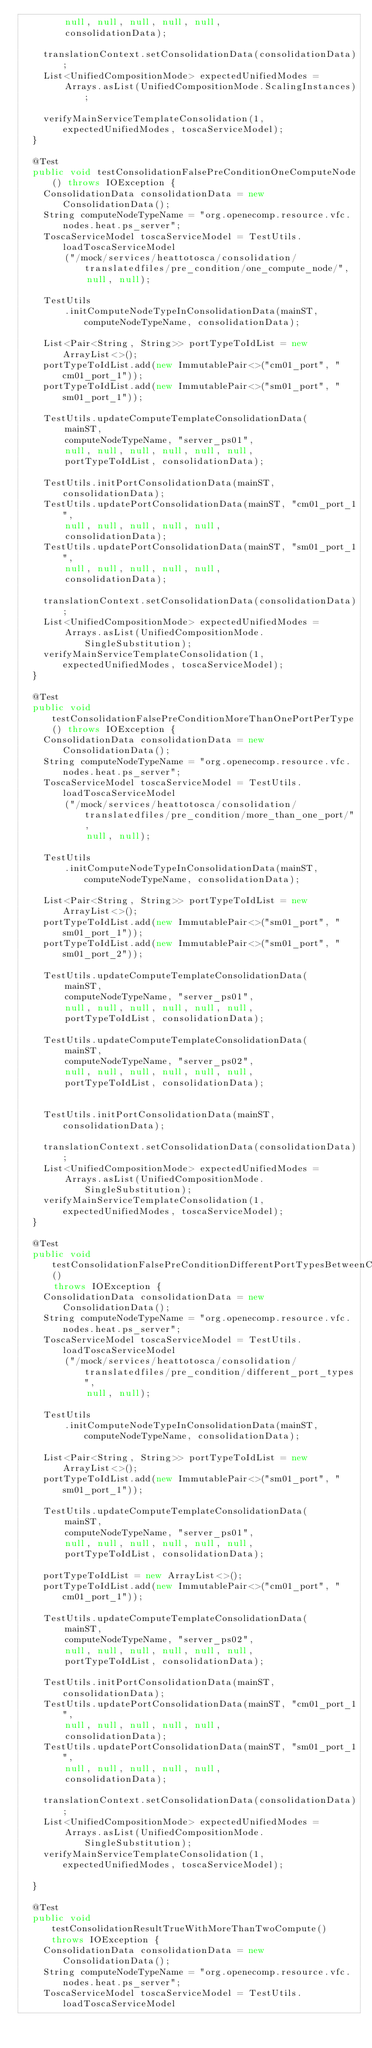<code> <loc_0><loc_0><loc_500><loc_500><_Java_>        null, null, null, null, null,
        consolidationData);

    translationContext.setConsolidationData(consolidationData);
    List<UnifiedCompositionMode> expectedUnifiedModes =
        Arrays.asList(UnifiedCompositionMode.ScalingInstances);

    verifyMainServiceTemplateConsolidation(1, expectedUnifiedModes, toscaServiceModel);
  }

  @Test
  public void testConsolidationFalsePreConditionOneComputeNode() throws IOException {
    ConsolidationData consolidationData = new ConsolidationData();
    String computeNodeTypeName = "org.openecomp.resource.vfc.nodes.heat.ps_server";
    ToscaServiceModel toscaServiceModel = TestUtils.loadToscaServiceModel
        ("/mock/services/heattotosca/consolidation/translatedfiles/pre_condition/one_compute_node/",
            null, null);

    TestUtils
        .initComputeNodeTypeInConsolidationData(mainST, computeNodeTypeName, consolidationData);

    List<Pair<String, String>> portTypeToIdList = new ArrayList<>();
    portTypeToIdList.add(new ImmutablePair<>("cm01_port", "cm01_port_1"));
    portTypeToIdList.add(new ImmutablePair<>("sm01_port", "sm01_port_1"));

    TestUtils.updateComputeTemplateConsolidationData(
        mainST,
        computeNodeTypeName, "server_ps01",
        null, null, null, null, null, null,
        portTypeToIdList, consolidationData);

    TestUtils.initPortConsolidationData(mainST, consolidationData);
    TestUtils.updatePortConsolidationData(mainST, "cm01_port_1",
        null, null, null, null, null,
        consolidationData);
    TestUtils.updatePortConsolidationData(mainST, "sm01_port_1",
        null, null, null, null, null,
        consolidationData);

    translationContext.setConsolidationData(consolidationData);
    List<UnifiedCompositionMode> expectedUnifiedModes =
        Arrays.asList(UnifiedCompositionMode.SingleSubstitution);
    verifyMainServiceTemplateConsolidation(1, expectedUnifiedModes, toscaServiceModel);
  }

  @Test
  public void testConsolidationFalsePreConditionMoreThanOnePortPerType() throws IOException {
    ConsolidationData consolidationData = new ConsolidationData();
    String computeNodeTypeName = "org.openecomp.resource.vfc.nodes.heat.ps_server";
    ToscaServiceModel toscaServiceModel = TestUtils.loadToscaServiceModel
        ("/mock/services/heattotosca/consolidation/translatedfiles/pre_condition/more_than_one_port/",
            null, null);

    TestUtils
        .initComputeNodeTypeInConsolidationData(mainST, computeNodeTypeName, consolidationData);

    List<Pair<String, String>> portTypeToIdList = new ArrayList<>();
    portTypeToIdList.add(new ImmutablePair<>("sm01_port", "sm01_port_1"));
    portTypeToIdList.add(new ImmutablePair<>("sm01_port", "sm01_port_2"));

    TestUtils.updateComputeTemplateConsolidationData(
        mainST,
        computeNodeTypeName, "server_ps01",
        null, null, null, null, null, null,
        portTypeToIdList, consolidationData);

    TestUtils.updateComputeTemplateConsolidationData(
        mainST,
        computeNodeTypeName, "server_ps02",
        null, null, null, null, null, null,
        portTypeToIdList, consolidationData);


    TestUtils.initPortConsolidationData(mainST, consolidationData);

    translationContext.setConsolidationData(consolidationData);
    List<UnifiedCompositionMode> expectedUnifiedModes =
        Arrays.asList(UnifiedCompositionMode.SingleSubstitution);
    verifyMainServiceTemplateConsolidation(1, expectedUnifiedModes, toscaServiceModel);
  }

  @Test
  public void testConsolidationFalsePreConditionDifferentPortTypesBetweenComputes()
      throws IOException {
    ConsolidationData consolidationData = new ConsolidationData();
    String computeNodeTypeName = "org.openecomp.resource.vfc.nodes.heat.ps_server";
    ToscaServiceModel toscaServiceModel = TestUtils.loadToscaServiceModel
        ("/mock/services/heattotosca/consolidation/translatedfiles/pre_condition/different_port_types",
            null, null);

    TestUtils
        .initComputeNodeTypeInConsolidationData(mainST, computeNodeTypeName, consolidationData);

    List<Pair<String, String>> portTypeToIdList = new ArrayList<>();
    portTypeToIdList.add(new ImmutablePair<>("sm01_port", "sm01_port_1"));

    TestUtils.updateComputeTemplateConsolidationData(
        mainST,
        computeNodeTypeName, "server_ps01",
        null, null, null, null, null, null,
        portTypeToIdList, consolidationData);

    portTypeToIdList = new ArrayList<>();
    portTypeToIdList.add(new ImmutablePair<>("cm01_port", "cm01_port_1"));

    TestUtils.updateComputeTemplateConsolidationData(
        mainST,
        computeNodeTypeName, "server_ps02",
        null, null, null, null, null, null,
        portTypeToIdList, consolidationData);

    TestUtils.initPortConsolidationData(mainST, consolidationData);
    TestUtils.updatePortConsolidationData(mainST, "cm01_port_1",
        null, null, null, null, null,
        consolidationData);
    TestUtils.updatePortConsolidationData(mainST, "sm01_port_1",
        null, null, null, null, null,
        consolidationData);

    translationContext.setConsolidationData(consolidationData);
    List<UnifiedCompositionMode> expectedUnifiedModes =
        Arrays.asList(UnifiedCompositionMode.SingleSubstitution);
    verifyMainServiceTemplateConsolidation(1, expectedUnifiedModes, toscaServiceModel);

  }

  @Test
  public void testConsolidationResultTrueWithMoreThanTwoCompute() throws IOException {
    ConsolidationData consolidationData = new ConsolidationData();
    String computeNodeTypeName = "org.openecomp.resource.vfc.nodes.heat.ps_server";
    ToscaServiceModel toscaServiceModel = TestUtils.loadToscaServiceModel</code> 